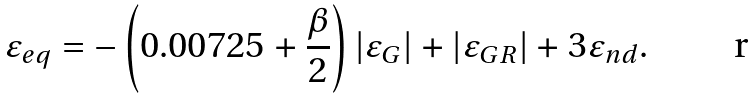Convert formula to latex. <formula><loc_0><loc_0><loc_500><loc_500>\varepsilon _ { e q } = - \left ( 0 . 0 0 7 2 5 + \frac { \beta } { 2 } \right ) | \varepsilon _ { G } | + | \varepsilon _ { G R } | + 3 \varepsilon _ { n d } .</formula> 